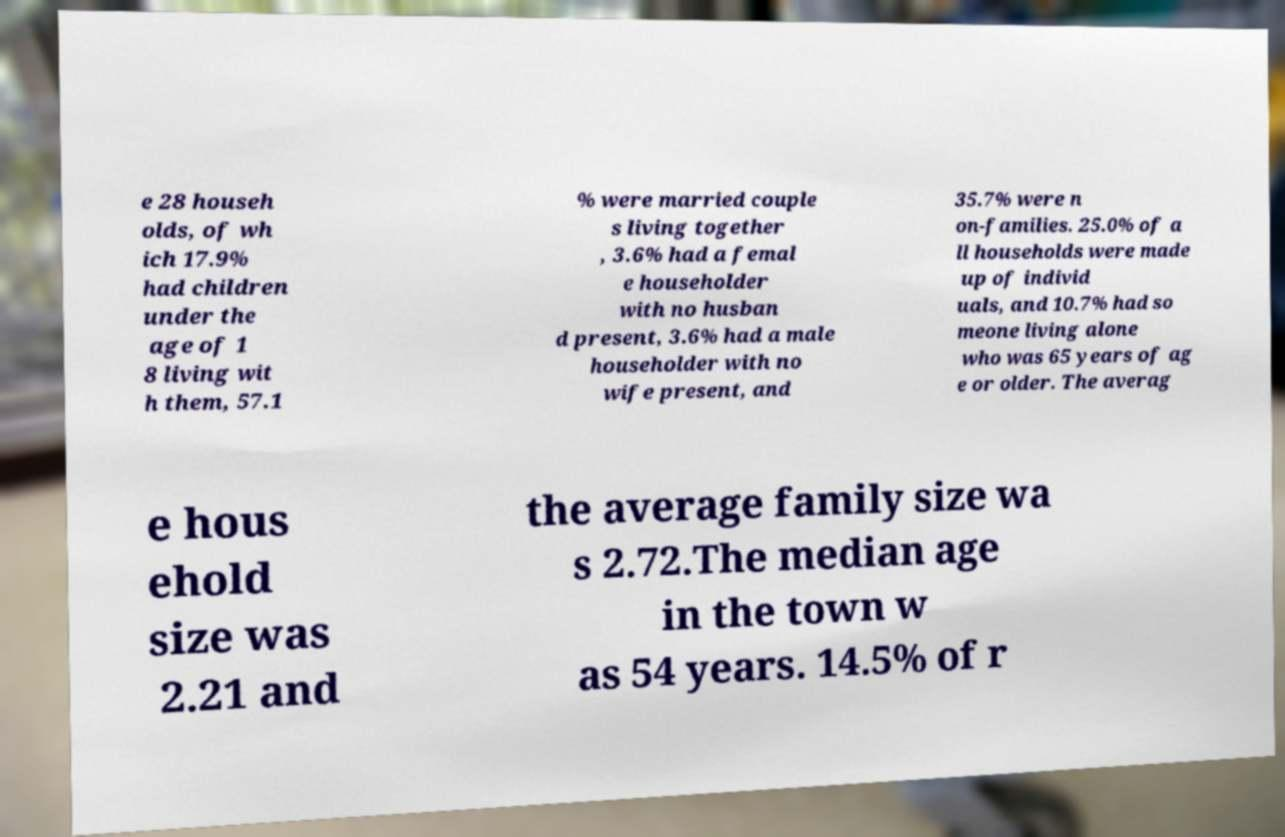Please identify and transcribe the text found in this image. e 28 househ olds, of wh ich 17.9% had children under the age of 1 8 living wit h them, 57.1 % were married couple s living together , 3.6% had a femal e householder with no husban d present, 3.6% had a male householder with no wife present, and 35.7% were n on-families. 25.0% of a ll households were made up of individ uals, and 10.7% had so meone living alone who was 65 years of ag e or older. The averag e hous ehold size was 2.21 and the average family size wa s 2.72.The median age in the town w as 54 years. 14.5% of r 